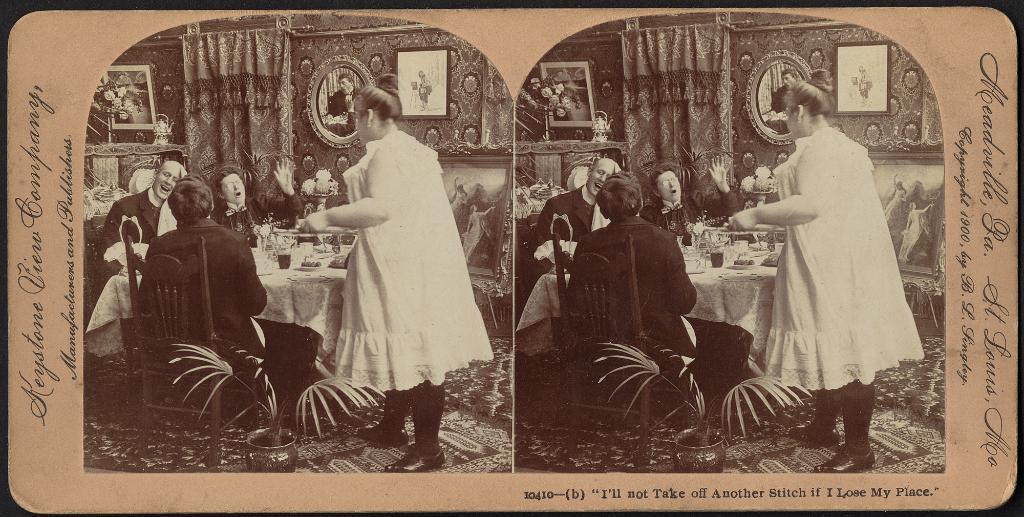Could you give a brief overview of what you see in this image? This is a picture of two photos that are stick to the paper, where there are three persons sitting on the chairs , a person standing, some items on the table, frames attached to the wall, curtain, carpet, plant in a photo , there is a same repeated photo on the other side of the paper and there are words on the paper. 